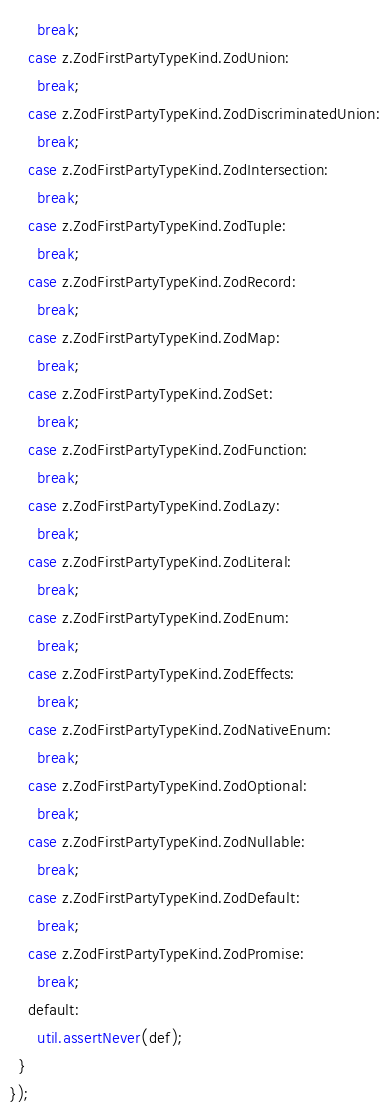<code> <loc_0><loc_0><loc_500><loc_500><_TypeScript_>      break;
    case z.ZodFirstPartyTypeKind.ZodUnion:
      break;
    case z.ZodFirstPartyTypeKind.ZodDiscriminatedUnion:
      break;
    case z.ZodFirstPartyTypeKind.ZodIntersection:
      break;
    case z.ZodFirstPartyTypeKind.ZodTuple:
      break;
    case z.ZodFirstPartyTypeKind.ZodRecord:
      break;
    case z.ZodFirstPartyTypeKind.ZodMap:
      break;
    case z.ZodFirstPartyTypeKind.ZodSet:
      break;
    case z.ZodFirstPartyTypeKind.ZodFunction:
      break;
    case z.ZodFirstPartyTypeKind.ZodLazy:
      break;
    case z.ZodFirstPartyTypeKind.ZodLiteral:
      break;
    case z.ZodFirstPartyTypeKind.ZodEnum:
      break;
    case z.ZodFirstPartyTypeKind.ZodEffects:
      break;
    case z.ZodFirstPartyTypeKind.ZodNativeEnum:
      break;
    case z.ZodFirstPartyTypeKind.ZodOptional:
      break;
    case z.ZodFirstPartyTypeKind.ZodNullable:
      break;
    case z.ZodFirstPartyTypeKind.ZodDefault:
      break;
    case z.ZodFirstPartyTypeKind.ZodPromise:
      break;
    default:
      util.assertNever(def);
  }
});
</code> 